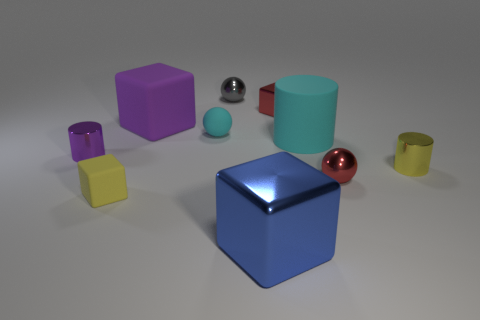What is the color of the cylinder left of the small matte cube?
Offer a terse response. Purple. There is a metal sphere left of the small red sphere; is its size the same as the rubber cube that is behind the yellow metal cylinder?
Your response must be concise. No. What number of things are either yellow shiny objects or small metal balls?
Ensure brevity in your answer.  3. There is a tiny yellow thing that is to the left of the big block that is in front of the cyan matte sphere; what is its material?
Offer a very short reply. Rubber. What number of other large things have the same shape as the gray metal object?
Keep it short and to the point. 0. Is there a large block of the same color as the tiny matte sphere?
Offer a terse response. No. How many things are gray metal objects behind the yellow shiny cylinder or large cyan cylinders that are to the right of the small purple cylinder?
Offer a terse response. 2. Are there any cylinders that are in front of the big thing that is in front of the cyan matte cylinder?
Offer a very short reply. No. There is a red thing that is the same size as the red cube; what shape is it?
Your answer should be compact. Sphere. What number of objects are either red metal things behind the yellow metal thing or small red blocks?
Your response must be concise. 1. 